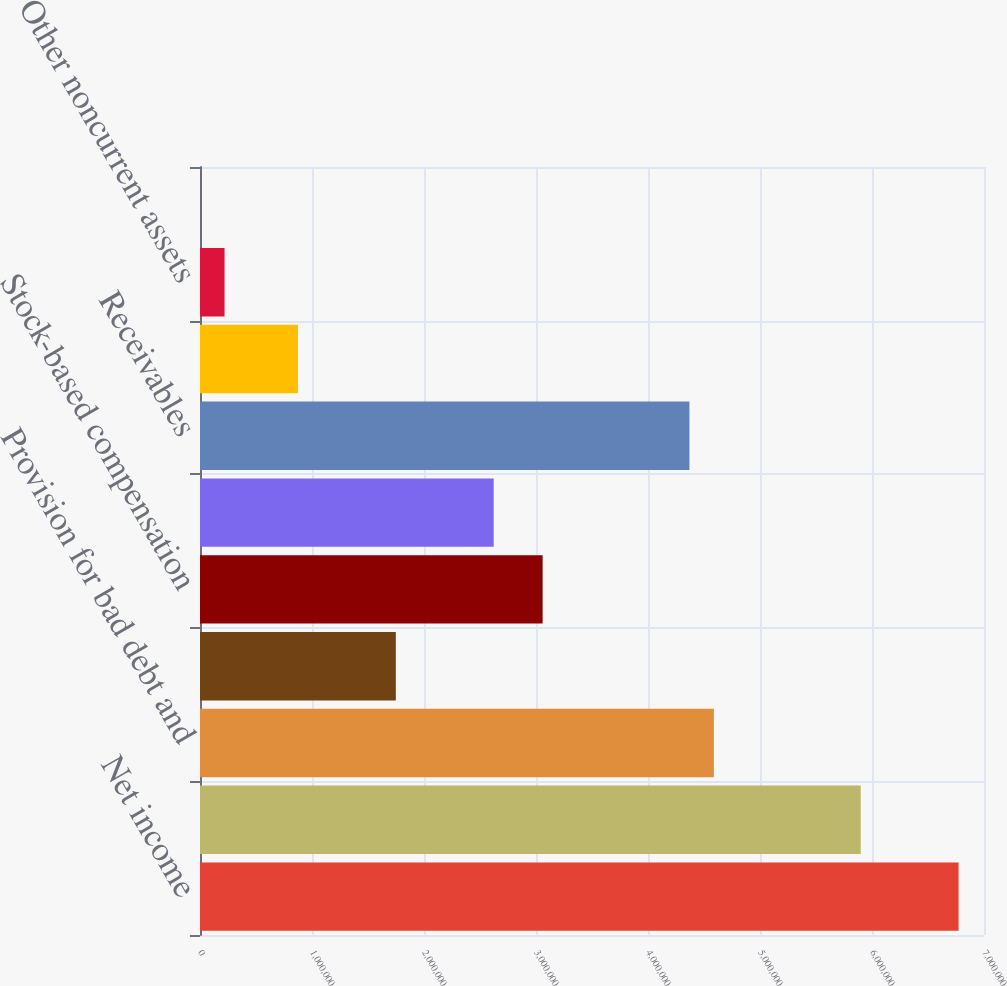Convert chart. <chart><loc_0><loc_0><loc_500><loc_500><bar_chart><fcel>Net income<fcel>Depreciation and amortization<fcel>Provision for bad debt and<fcel>Deferred taxes<fcel>Stock-based compensation<fcel>Cash and cash equivalents -<fcel>Receivables<fcel>Prepaid expenses and other<fcel>Other noncurrent assets<fcel>Accounts payable and accrued<nl><fcel>6.77302e+06<fcel>5.89917e+06<fcel>4.5884e+06<fcel>1.74838e+06<fcel>3.05916e+06<fcel>2.62223e+06<fcel>4.36993e+06<fcel>874531<fcel>219144<fcel>681<nl></chart> 